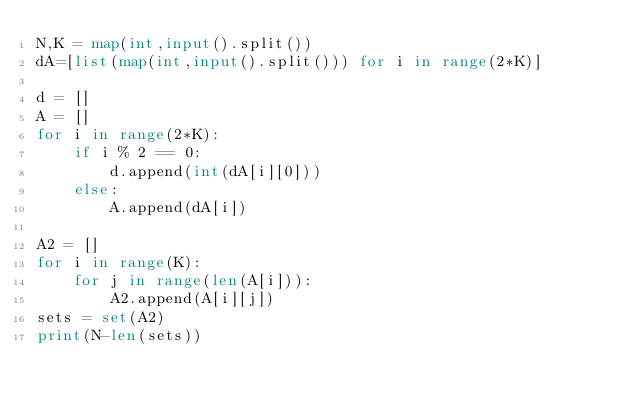<code> <loc_0><loc_0><loc_500><loc_500><_Python_>N,K = map(int,input().split())
dA=[list(map(int,input().split())) for i in range(2*K)]

d = []
A = []
for i in range(2*K):
    if i % 2 == 0:
        d.append(int(dA[i][0]))
    else:
        A.append(dA[i])

A2 = []
for i in range(K):
    for j in range(len(A[i])):
        A2.append(A[i][j])
sets = set(A2)
print(N-len(sets))</code> 